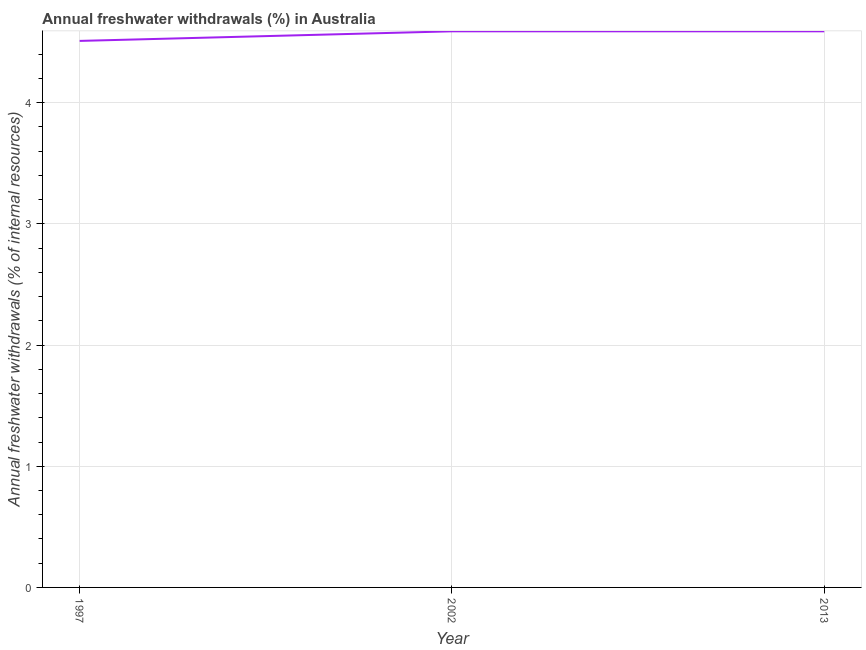What is the annual freshwater withdrawals in 2002?
Your answer should be compact. 4.59. Across all years, what is the maximum annual freshwater withdrawals?
Keep it short and to the point. 4.59. Across all years, what is the minimum annual freshwater withdrawals?
Make the answer very short. 4.51. In which year was the annual freshwater withdrawals maximum?
Make the answer very short. 2002. What is the sum of the annual freshwater withdrawals?
Provide a succinct answer. 13.69. What is the average annual freshwater withdrawals per year?
Your response must be concise. 4.56. What is the median annual freshwater withdrawals?
Your answer should be compact. 4.59. In how many years, is the annual freshwater withdrawals greater than 2.4 %?
Your response must be concise. 3. Is the difference between the annual freshwater withdrawals in 1997 and 2013 greater than the difference between any two years?
Give a very brief answer. Yes. What is the difference between the highest and the second highest annual freshwater withdrawals?
Your answer should be compact. 0. Is the sum of the annual freshwater withdrawals in 2002 and 2013 greater than the maximum annual freshwater withdrawals across all years?
Your answer should be compact. Yes. What is the difference between the highest and the lowest annual freshwater withdrawals?
Your answer should be very brief. 0.08. In how many years, is the annual freshwater withdrawals greater than the average annual freshwater withdrawals taken over all years?
Your answer should be very brief. 2. How many lines are there?
Keep it short and to the point. 1. Are the values on the major ticks of Y-axis written in scientific E-notation?
Give a very brief answer. No. What is the title of the graph?
Provide a short and direct response. Annual freshwater withdrawals (%) in Australia. What is the label or title of the X-axis?
Offer a very short reply. Year. What is the label or title of the Y-axis?
Your response must be concise. Annual freshwater withdrawals (% of internal resources). What is the Annual freshwater withdrawals (% of internal resources) of 1997?
Offer a terse response. 4.51. What is the Annual freshwater withdrawals (% of internal resources) of 2002?
Your answer should be very brief. 4.59. What is the Annual freshwater withdrawals (% of internal resources) in 2013?
Your answer should be compact. 4.59. What is the difference between the Annual freshwater withdrawals (% of internal resources) in 1997 and 2002?
Make the answer very short. -0.08. What is the difference between the Annual freshwater withdrawals (% of internal resources) in 1997 and 2013?
Offer a very short reply. -0.08. What is the difference between the Annual freshwater withdrawals (% of internal resources) in 2002 and 2013?
Your answer should be very brief. 0. What is the ratio of the Annual freshwater withdrawals (% of internal resources) in 1997 to that in 2013?
Your answer should be very brief. 0.98. 